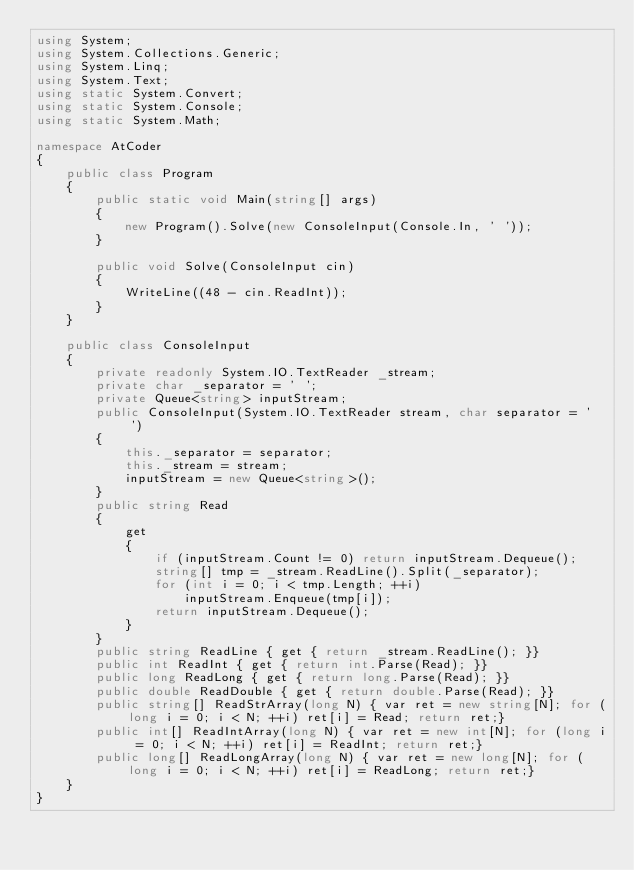<code> <loc_0><loc_0><loc_500><loc_500><_C#_>using System;
using System.Collections.Generic;
using System.Linq;
using System.Text;
using static System.Convert;
using static System.Console;
using static System.Math;

namespace AtCoder
{
    public class Program
    {
        public static void Main(string[] args)
        {
            new Program().Solve(new ConsoleInput(Console.In, ' '));
        }

        public void Solve(ConsoleInput cin)
        {
            WriteLine((48 - cin.ReadInt));
        }
    }

    public class ConsoleInput
    {
        private readonly System.IO.TextReader _stream;
        private char _separator = ' ';
        private Queue<string> inputStream;
        public ConsoleInput(System.IO.TextReader stream, char separator = ' ')
        {
            this._separator = separator;
            this._stream = stream;
            inputStream = new Queue<string>();
        }
        public string Read
        {
            get
            {
                if (inputStream.Count != 0) return inputStream.Dequeue();
                string[] tmp = _stream.ReadLine().Split(_separator);
                for (int i = 0; i < tmp.Length; ++i)
                    inputStream.Enqueue(tmp[i]);
                return inputStream.Dequeue();
            }
        }
        public string ReadLine { get { return _stream.ReadLine(); }}
        public int ReadInt { get { return int.Parse(Read); }}
        public long ReadLong { get { return long.Parse(Read); }}
        public double ReadDouble { get { return double.Parse(Read); }}
        public string[] ReadStrArray(long N) { var ret = new string[N]; for (long i = 0; i < N; ++i) ret[i] = Read; return ret;}
        public int[] ReadIntArray(long N) { var ret = new int[N]; for (long i = 0; i < N; ++i) ret[i] = ReadInt; return ret;}
        public long[] ReadLongArray(long N) { var ret = new long[N]; for (long i = 0; i < N; ++i) ret[i] = ReadLong; return ret;}
    }
}</code> 